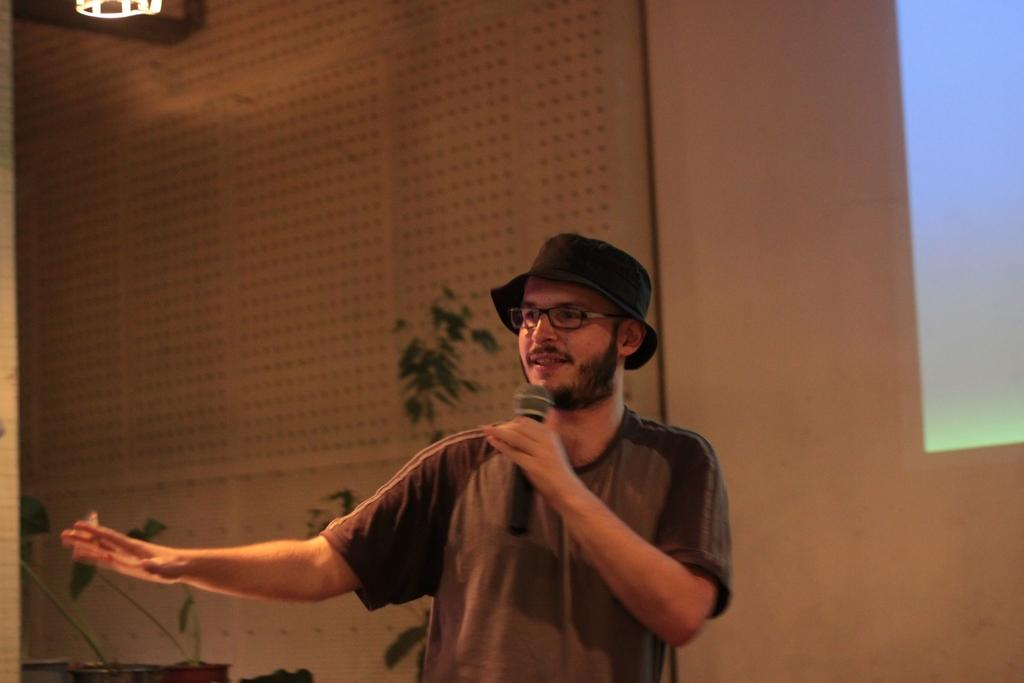What is the man in the foreground of the image doing? The man is standing in the foreground of the image and holding a mic. What can be seen in the image besides the man? There are plants, a wall, and a screen visible in the image. What is the object at the top of the image? There is an object at the top of the image, but it is not clear what it is from the provided facts. What is the background of the image? There is a wall in the background of the image. What type of soda is being poured into the basin in the image? There is no soda or basin present in the image. What is the man walking on in the image? The man is standing in the image, not walking, and there is no sidewalk or other surface mentioned in the provided facts. 